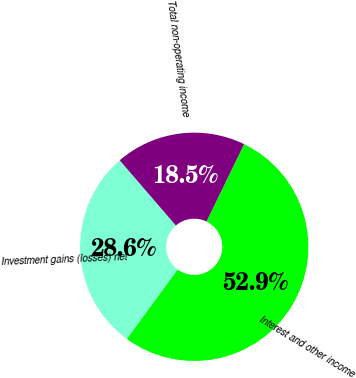Convert chart. <chart><loc_0><loc_0><loc_500><loc_500><pie_chart><fcel>Interest and other income<fcel>Investment gains (losses) net<fcel>Total non-operating income<nl><fcel>52.86%<fcel>28.62%<fcel>18.52%<nl></chart> 